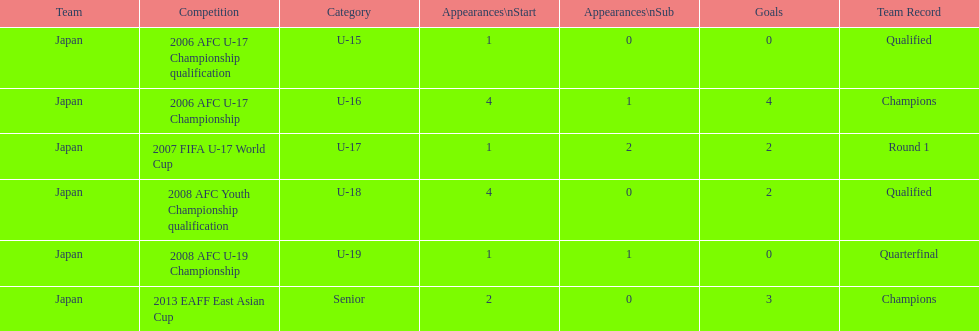Could you help me parse every detail presented in this table? {'header': ['Team', 'Competition', 'Category', 'Appearances\\nStart', 'Appearances\\nSub', 'Goals', 'Team Record'], 'rows': [['Japan', '2006 AFC U-17 Championship qualification', 'U-15', '1', '0', '0', 'Qualified'], ['Japan', '2006 AFC U-17 Championship', 'U-16', '4', '1', '4', 'Champions'], ['Japan', '2007 FIFA U-17 World Cup', 'U-17', '1', '2', '2', 'Round 1'], ['Japan', '2008 AFC Youth Championship qualification', 'U-18', '4', '0', '2', 'Qualified'], ['Japan', '2008 AFC U-19 Championship', 'U-19', '1', '1', '0', 'Quarterfinal'], ['Japan', '2013 EAFF East Asian Cup', 'Senior', '2', '0', '3', 'Champions']]} In which number of significant competitions did yoichiro kakitani achieve over two goals? 2. 